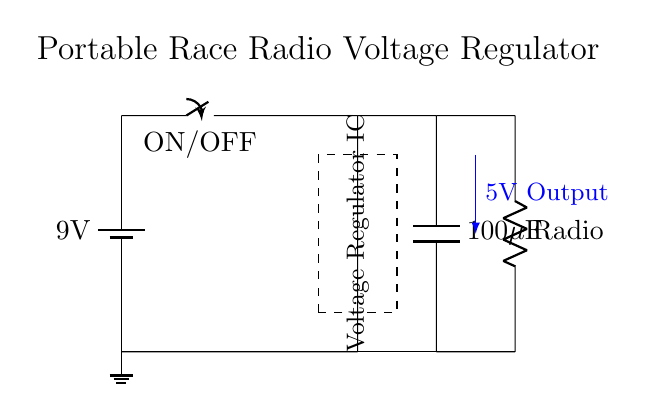What is the battery voltage in this circuit? The battery voltage is labeled as 9 volts on the circuit diagram. This is indicated next to the battery symbol.
Answer: 9 volts What is the output voltage of the voltage regulator? The output voltage is labeled as 5 volts, which comes from the voltage regulator section of the circuit connecting to the load (radio).
Answer: 5 volts What type of load is depicted in this circuit? The load in this circuit is a radio, identified by the label next to the resistor symbol denoting it.
Answer: Radio What is the capacitance value of the output capacitor? The output capacitor has a capacitance value labeled as 100 microfarads, shown next to the capacitor symbol in the circuit diagram.
Answer: 100 microfarads Why is a voltage regulator used in this circuit? The voltage regulator is necessary to convert the higher battery voltage down to a stable 5 volts, which is suitable for the radio, ensuring proper operation. This is inferred from the presence of the voltage regulator IC and its output label.
Answer: To provide stable voltage How does the on/off switch affect the operation of the circuit? The on/off switch controls the connection from the battery to the rest of the circuit, allowing the user to turn the radio on or off. When the switch is in the "on" position, it completes the circuit, enabling current flow.
Answer: It controls power to the circuit 